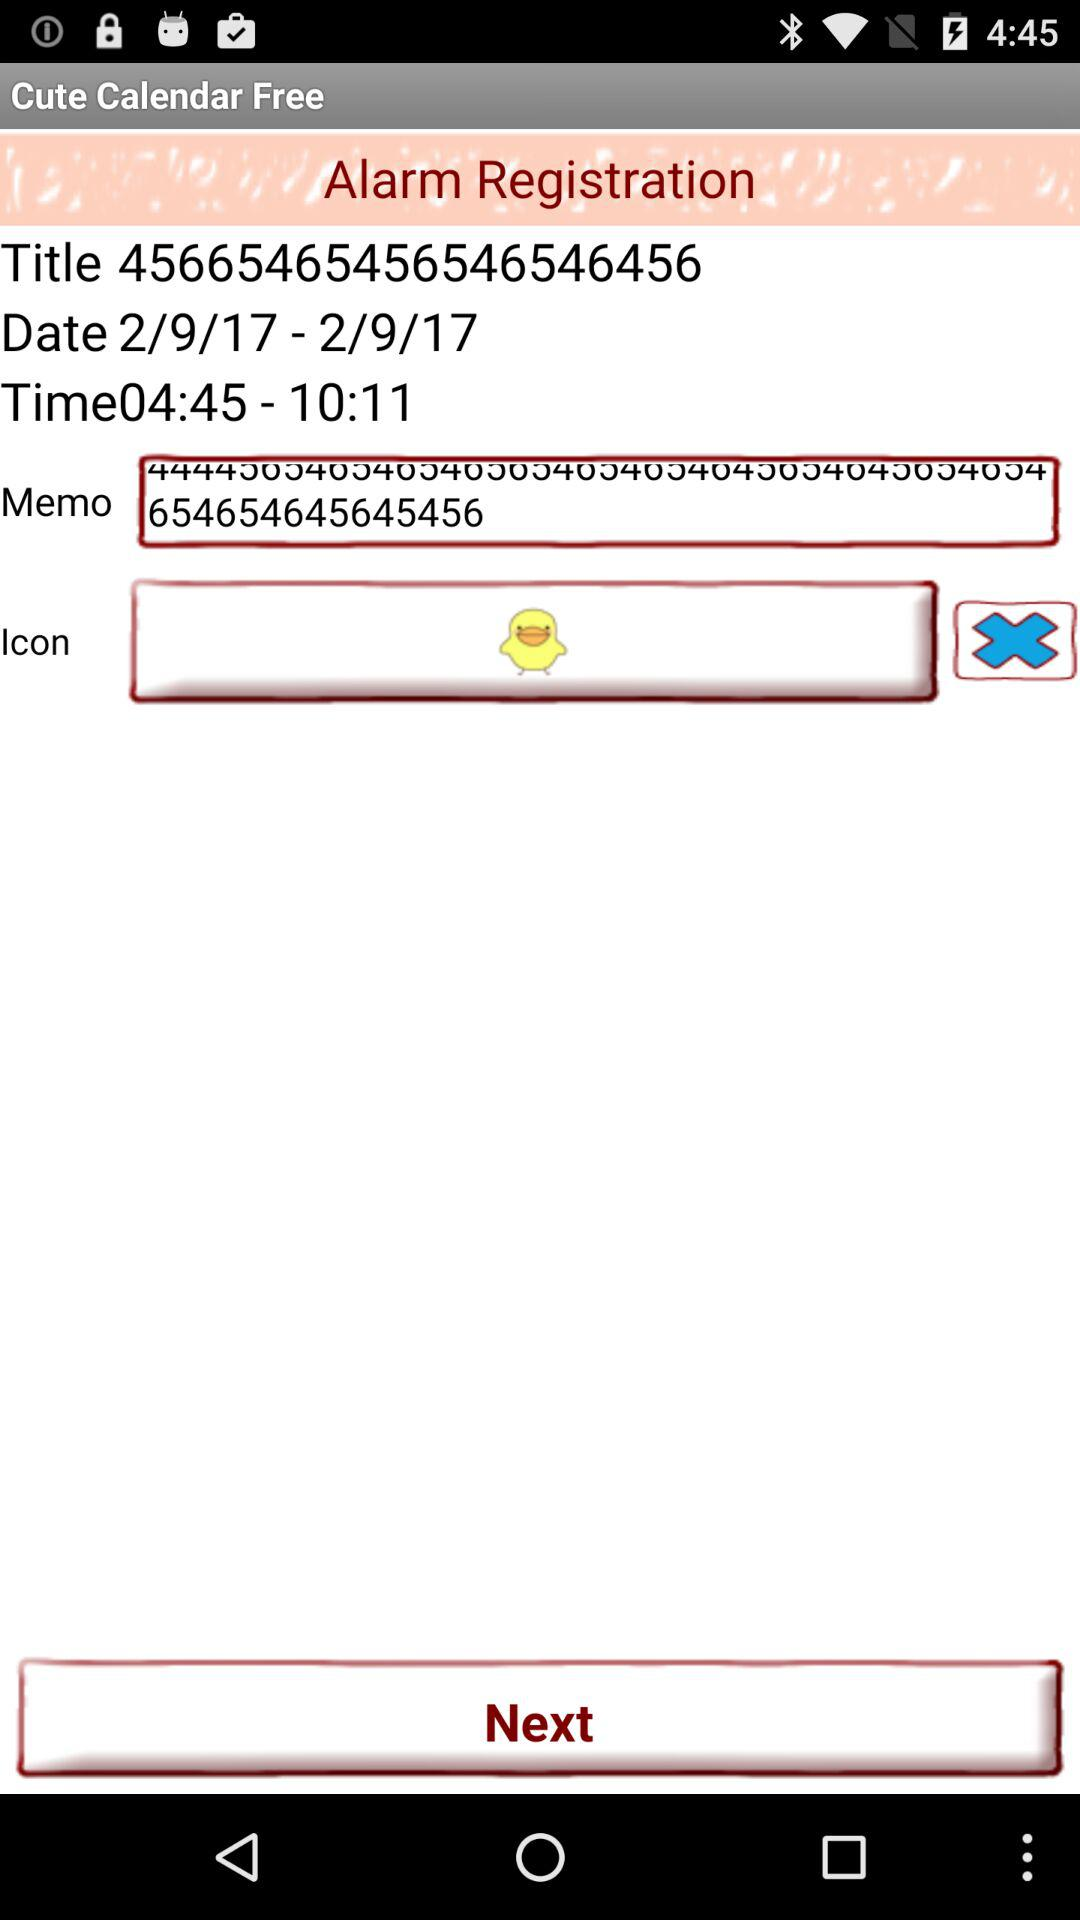What is the title? The title is 45665465456546546456. 